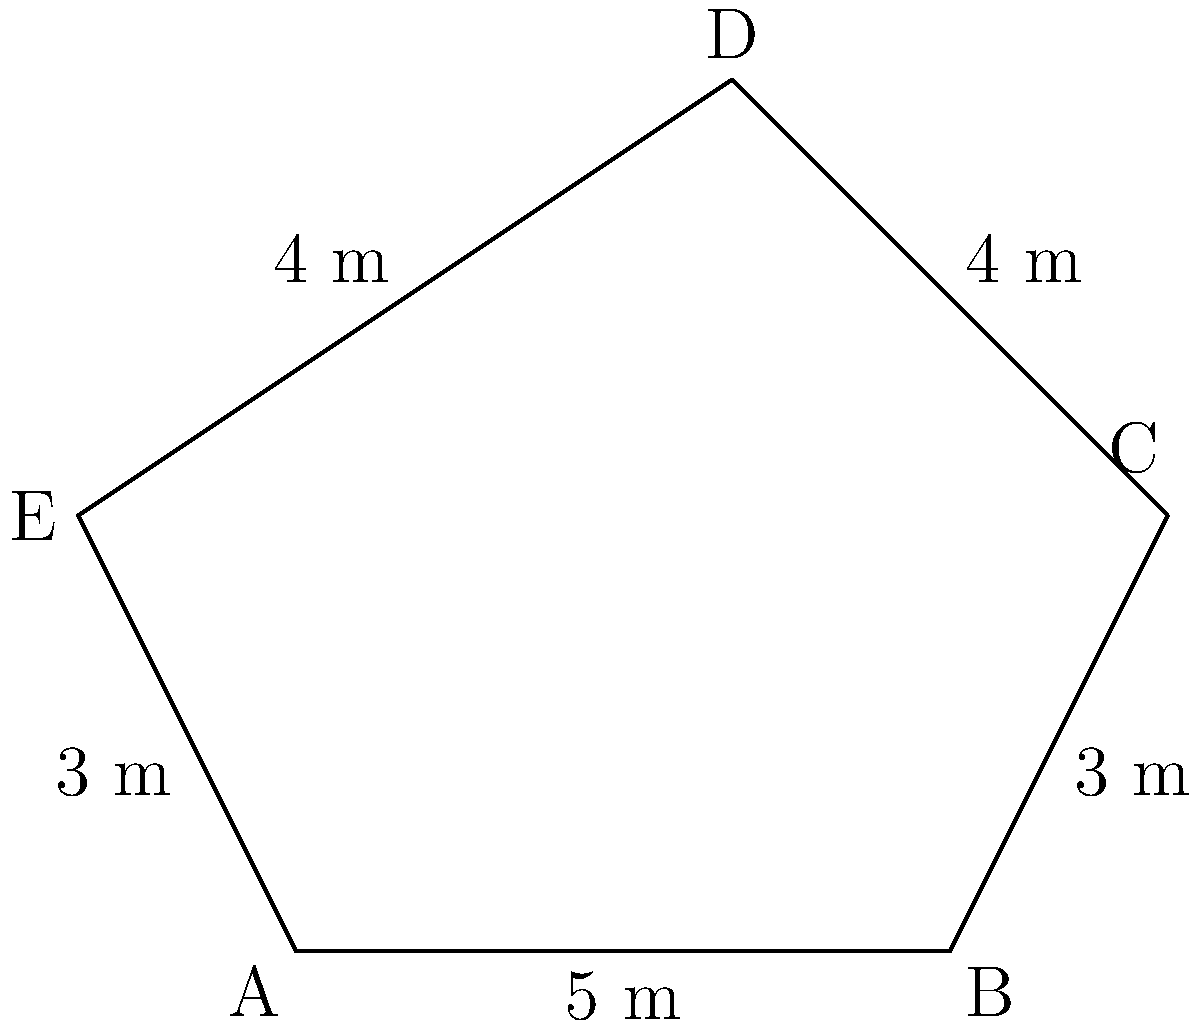In the Scottish highlands, a restored Covenanter-era castle features a unique pentagonal tower base. The sides of this pentagonal base measure 5 m, 3 m, 4 m, 4 m, and 3 m in order. Calculate the area of this pentagonal tower base. To find the area of an irregular pentagon, we can divide it into triangles and sum their areas. Here's how:

1) First, let's divide the pentagon into three triangles by drawing diagonals from one vertex to the non-adjacent vertices.

2) We can use Heron's formula to calculate the area of each triangle. Heron's formula states:

   $A = \sqrt{s(s-a)(s-b)(s-c)}$

   where $A$ is the area, $s$ is the semi-perimeter $(a+b+c)/2$, and $a$, $b$, and $c$ are the side lengths.

3) For the first triangle (5, 3, 4):
   $s = (5+3+4)/2 = 6$
   $A_1 = \sqrt{6(6-5)(6-3)(6-4)} = \sqrt{6 \cdot 1 \cdot 3 \cdot 2} = \sqrt{36} = 6$ m²

4) For the second triangle (5, 4, 4):
   $s = (5+4+4)/2 = 6.5$
   $A_2 = \sqrt{6.5(6.5-5)(6.5-4)(6.5-4)} = \sqrt{6.5 \cdot 1.5 \cdot 2.5 \cdot 2.5} = \sqrt{60.9375} \approx 7.81$ m²

5) For the third triangle (3, 4, 3):
   $s = (3+4+3)/2 = 5$
   $A_3 = \sqrt{5(5-3)(5-4)(5-3)} = \sqrt{5 \cdot 2 \cdot 1 \cdot 2} = \sqrt{20} \approx 4.47$ m²

6) The total area is the sum of these three triangles:
   $A_{total} = A_1 + A_2 + A_3 = 6 + 7.81 + 4.47 = 18.28$ m²

Therefore, the area of the pentagonal tower base is approximately 18.28 square meters.
Answer: 18.28 m² 